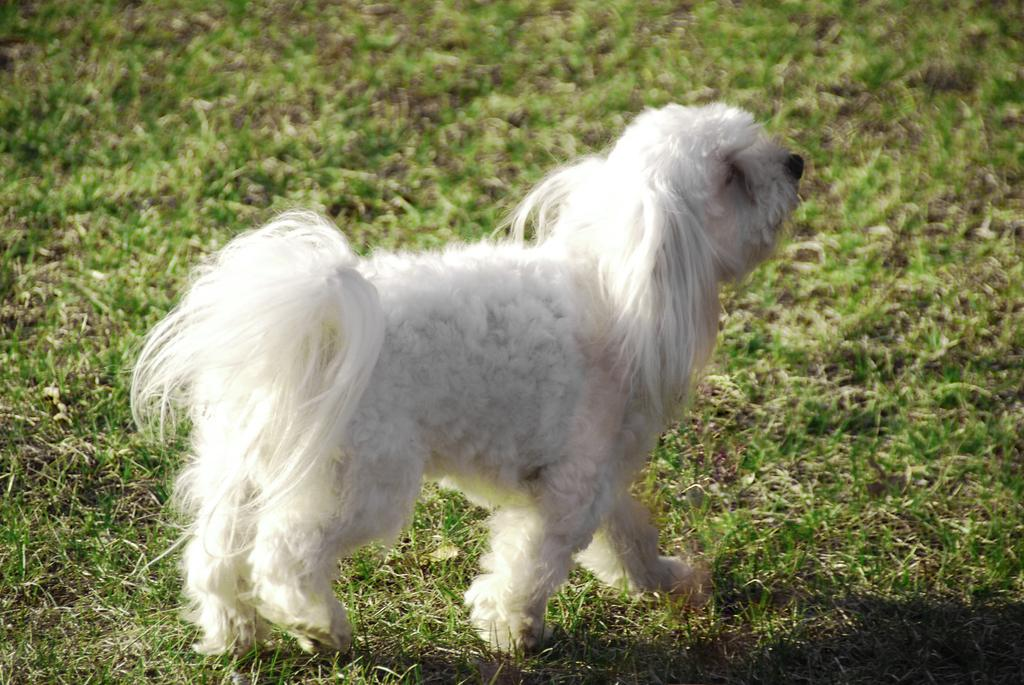What type of animal is present in the image? There is a dog in the image. What is the dog doing in the image? The dog is walking in the image. What surface is the dog walking on? The dog is walking on the surface of the grass. What type of food is the dog eating in the image? There is no food present in the image, and the dog is not eating anything. 